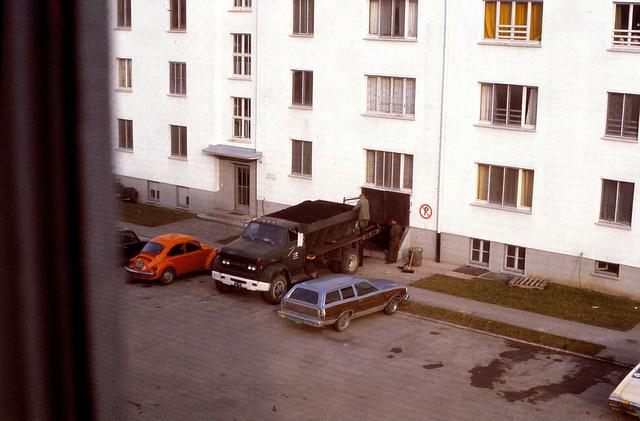Why is the truck backed up to the building?

Choices:
A) loading
B) robbery
C) blocking door
D) sales loading 